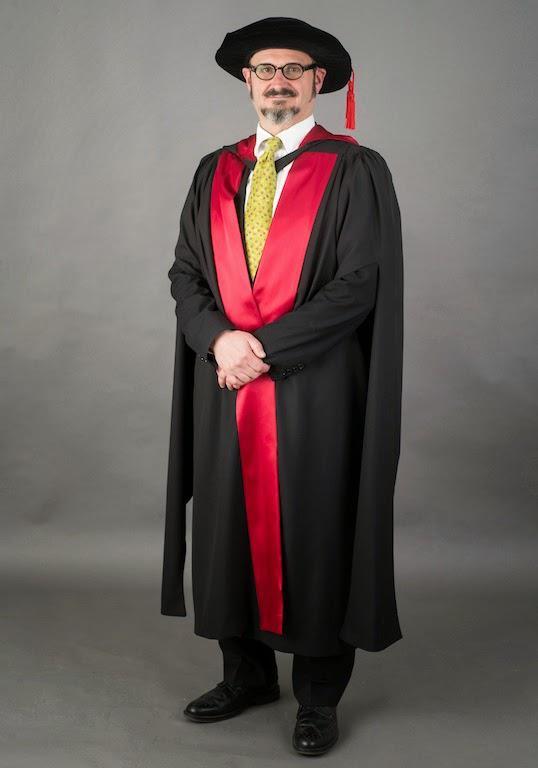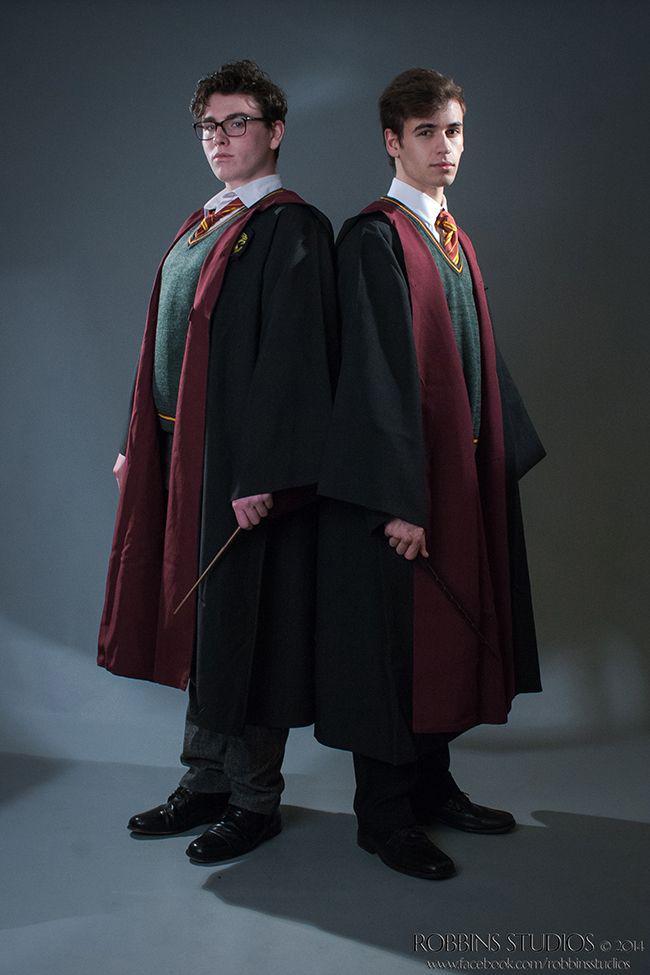The first image is the image on the left, the second image is the image on the right. Considering the images on both sides, is "A person is not shown in any of the images." valid? Answer yes or no. No. 